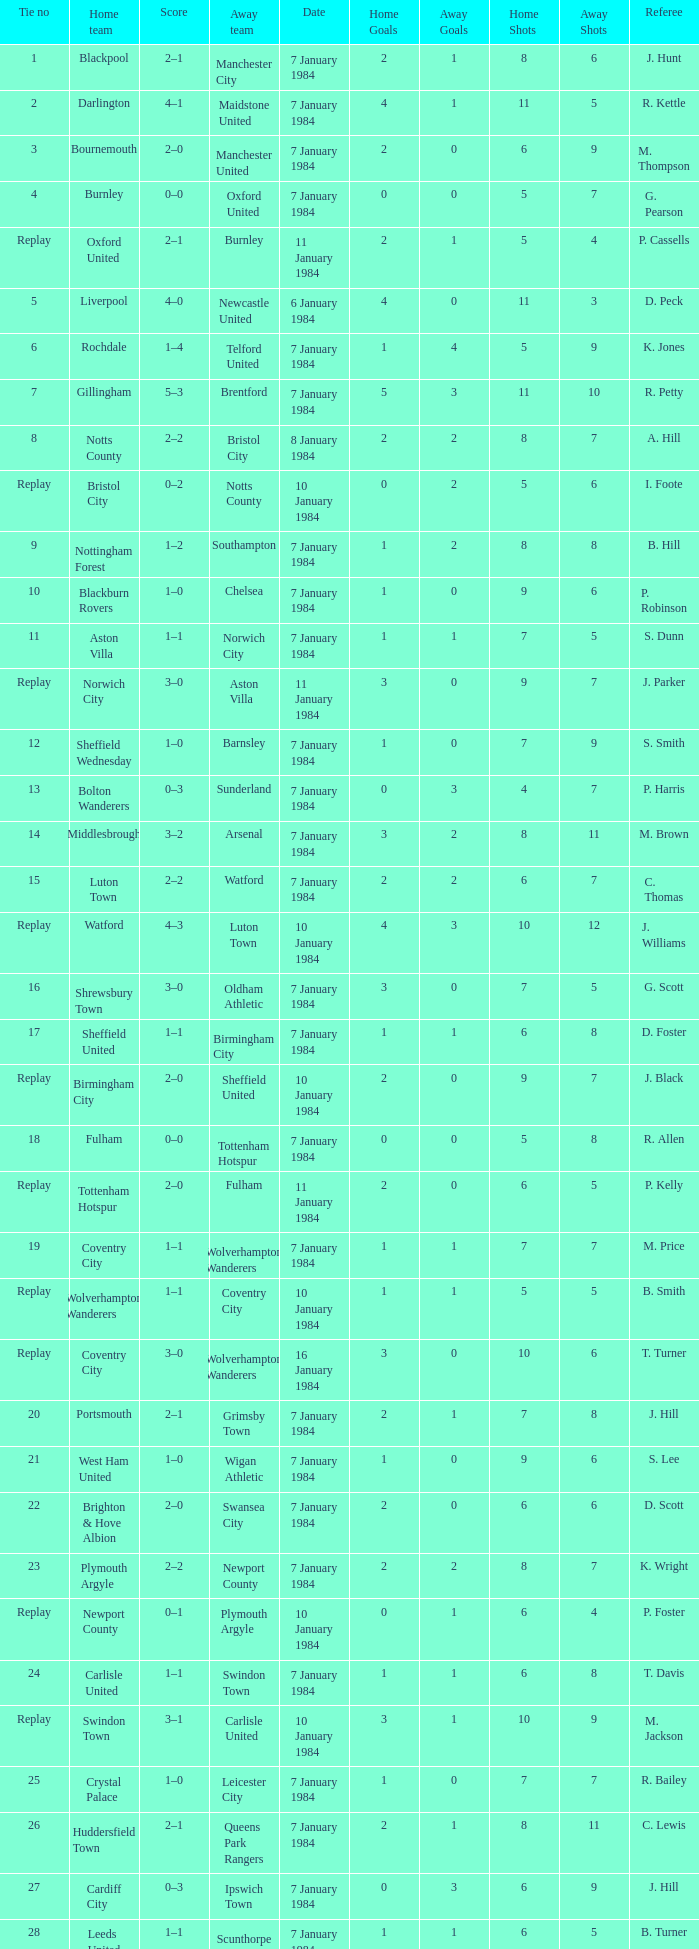Who was the away team against the home team Sheffield United? Birmingham City. 